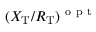<formula> <loc_0><loc_0><loc_500><loc_500>( X _ { T } / R _ { T } ) ^ { o p t }</formula> 